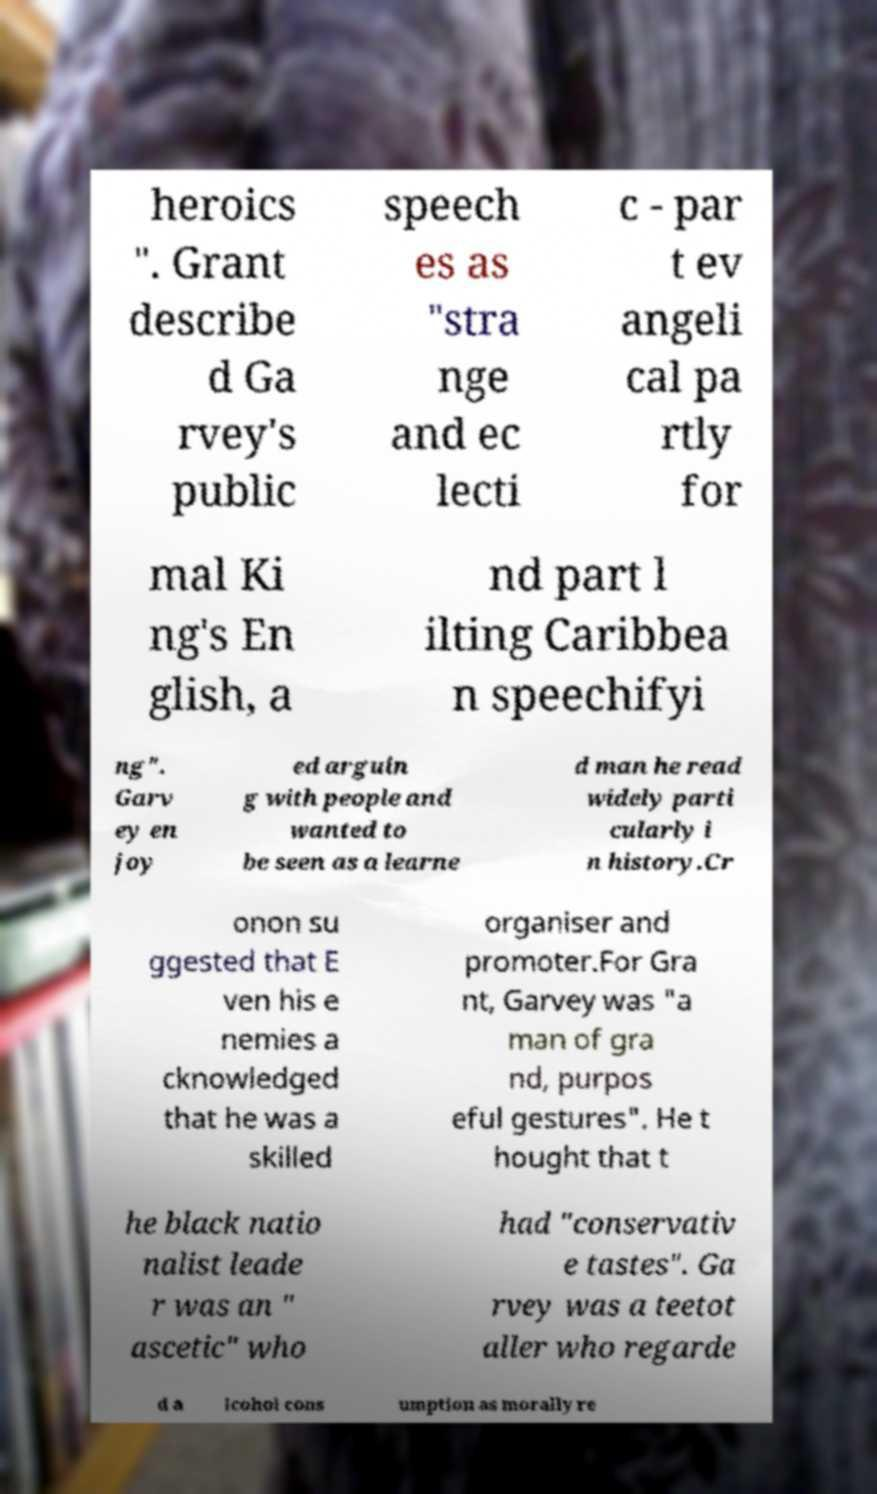Please read and relay the text visible in this image. What does it say? heroics ". Grant describe d Ga rvey's public speech es as "stra nge and ec lecti c - par t ev angeli cal pa rtly for mal Ki ng's En glish, a nd part l ilting Caribbea n speechifyi ng". Garv ey en joy ed arguin g with people and wanted to be seen as a learne d man he read widely parti cularly i n history.Cr onon su ggested that E ven his e nemies a cknowledged that he was a skilled organiser and promoter.For Gra nt, Garvey was "a man of gra nd, purpos eful gestures". He t hought that t he black natio nalist leade r was an " ascetic" who had "conservativ e tastes". Ga rvey was a teetot aller who regarde d a lcohol cons umption as morally re 